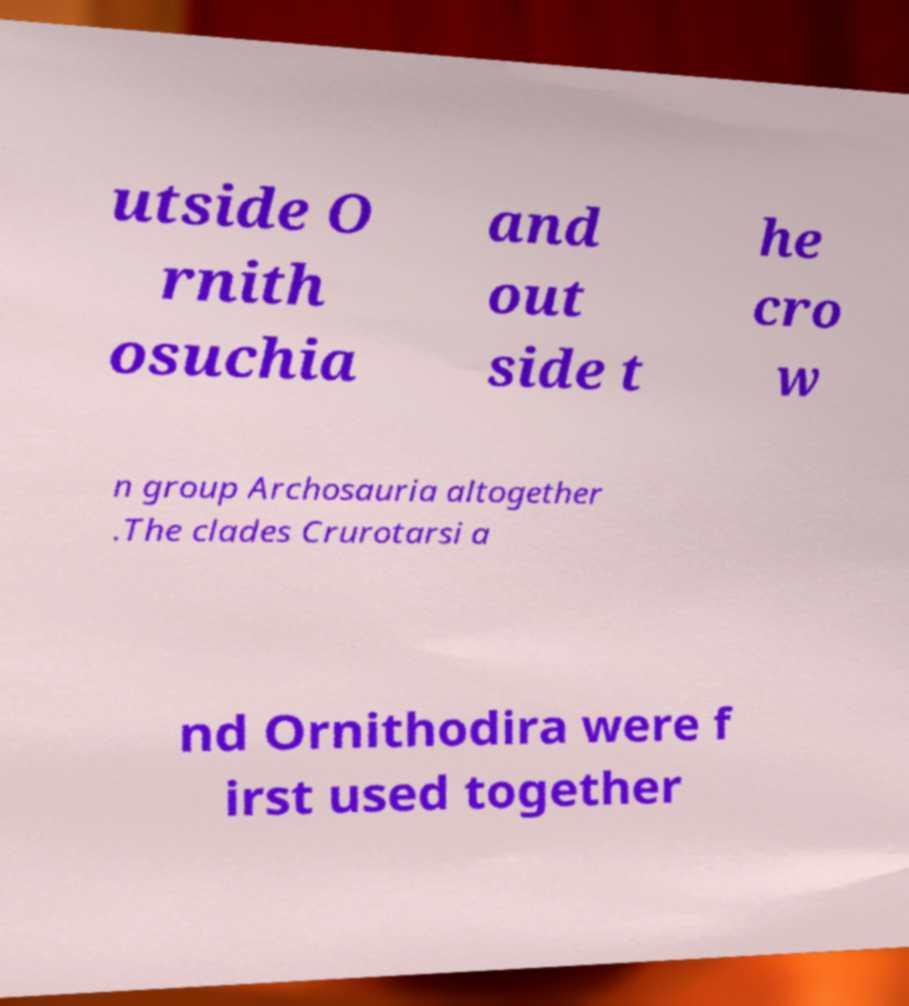Please read and relay the text visible in this image. What does it say? utside O rnith osuchia and out side t he cro w n group Archosauria altogether .The clades Crurotarsi a nd Ornithodira were f irst used together 